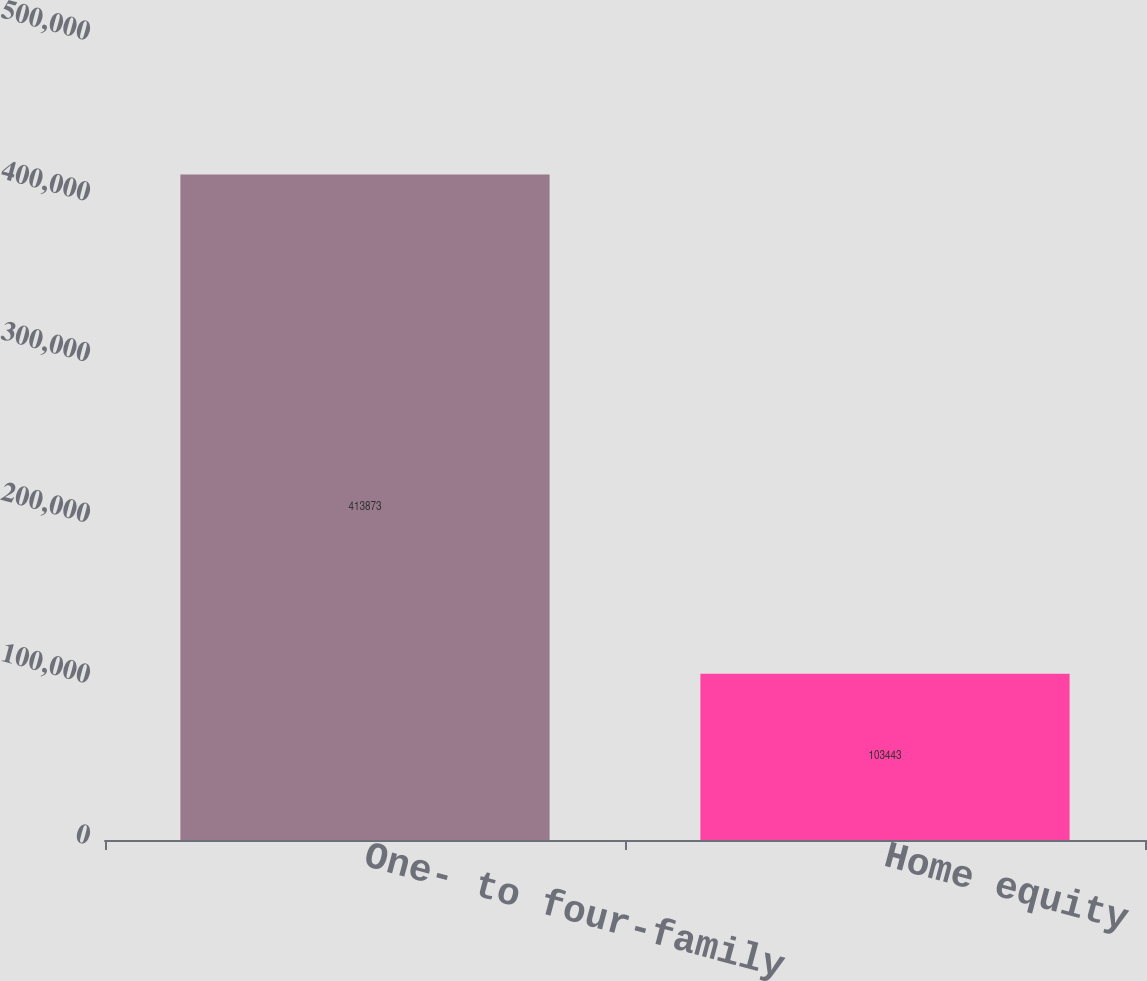Convert chart. <chart><loc_0><loc_0><loc_500><loc_500><bar_chart><fcel>One- to four-family<fcel>Home equity<nl><fcel>413873<fcel>103443<nl></chart> 